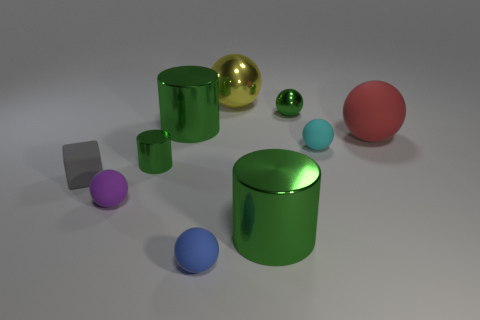What number of green objects are behind the tiny matte sphere that is to the left of the tiny blue object?
Ensure brevity in your answer.  3. There is a tiny rubber thing right of the blue matte sphere; what shape is it?
Provide a short and direct response. Sphere. What material is the tiny green thing that is on the right side of the small ball in front of the large shiny cylinder that is in front of the small gray block made of?
Offer a terse response. Metal. What number of other things are there of the same size as the blue matte object?
Provide a short and direct response. 5. There is a large yellow thing that is the same shape as the large red rubber thing; what material is it?
Keep it short and to the point. Metal. What color is the big matte thing?
Provide a short and direct response. Red. There is a big cylinder that is to the left of the large green metallic cylinder that is on the right side of the yellow thing; what is its color?
Provide a succinct answer. Green. There is a tiny metallic cylinder; is it the same color as the large metal cylinder behind the tiny rubber cube?
Offer a terse response. Yes. How many things are in front of the tiny green metallic object that is to the left of the large green metal thing that is in front of the small cube?
Your response must be concise. 4. Are there any red objects on the left side of the small green sphere?
Make the answer very short. No. 